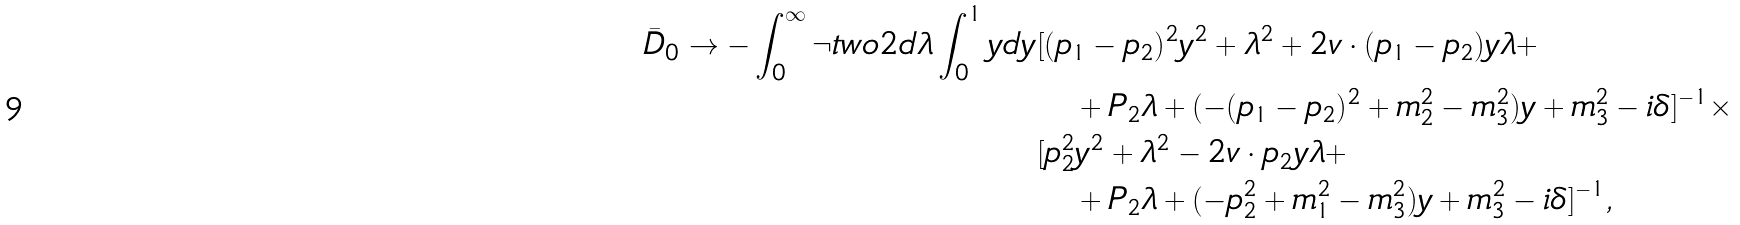Convert formula to latex. <formula><loc_0><loc_0><loc_500><loc_500>\bar { D } _ { 0 } \to - \int _ { 0 } ^ { \infty } \neg t w o 2 d \lambda \int _ { 0 } ^ { 1 } y d y & [ ( p _ { 1 } - p _ { 2 } ) ^ { 2 } y ^ { 2 } + \lambda ^ { 2 } + 2 v \cdot ( p _ { 1 } - p _ { 2 } ) y \lambda + \\ & \quad + P _ { 2 } \lambda + ( - ( p _ { 1 } - p _ { 2 } ) ^ { 2 } + m _ { 2 } ^ { 2 } - m _ { 3 } ^ { 2 } ) y + m _ { 3 } ^ { 2 } - i \delta ] ^ { - 1 } \times \\ & [ p _ { 2 } ^ { 2 } y ^ { 2 } + \lambda ^ { 2 } - 2 v \cdot p _ { 2 } y \lambda + \\ & \quad + P _ { 2 } \lambda + ( - p _ { 2 } ^ { 2 } + m _ { 1 } ^ { 2 } - m _ { 3 } ^ { 2 } ) y + m _ { 3 } ^ { 2 } - i \delta ] ^ { - 1 } ,</formula> 